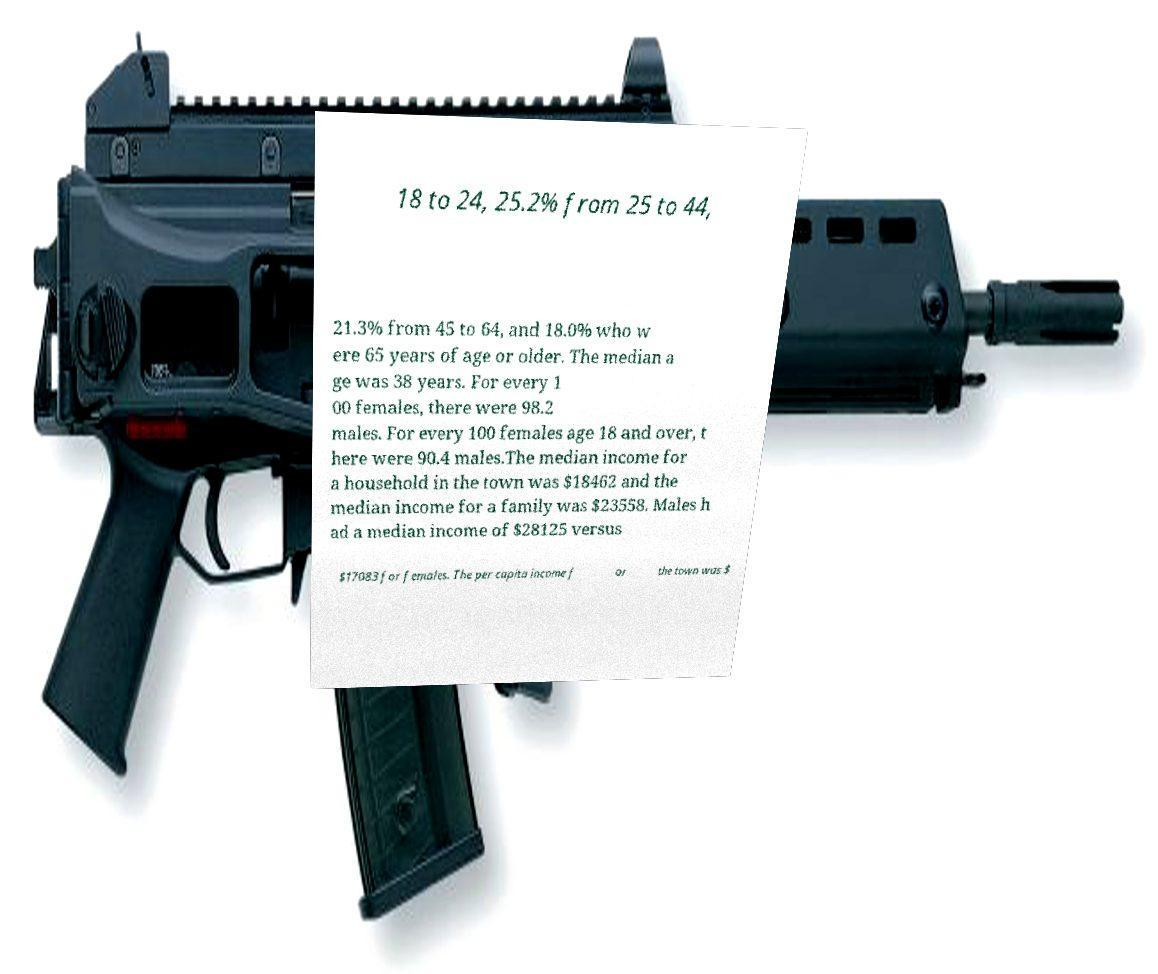Can you read and provide the text displayed in the image?This photo seems to have some interesting text. Can you extract and type it out for me? 18 to 24, 25.2% from 25 to 44, 21.3% from 45 to 64, and 18.0% who w ere 65 years of age or older. The median a ge was 38 years. For every 1 00 females, there were 98.2 males. For every 100 females age 18 and over, t here were 90.4 males.The median income for a household in the town was $18462 and the median income for a family was $23558. Males h ad a median income of $28125 versus $17083 for females. The per capita income f or the town was $ 